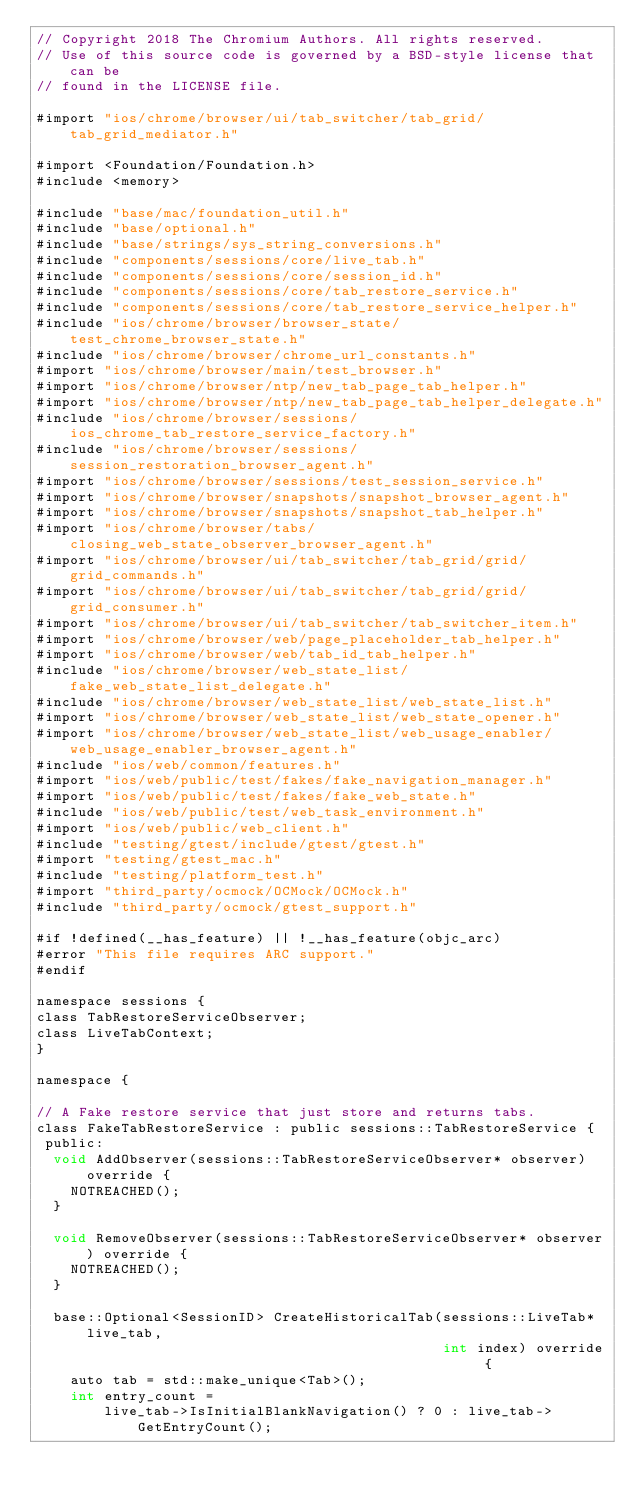<code> <loc_0><loc_0><loc_500><loc_500><_ObjectiveC_>// Copyright 2018 The Chromium Authors. All rights reserved.
// Use of this source code is governed by a BSD-style license that can be
// found in the LICENSE file.

#import "ios/chrome/browser/ui/tab_switcher/tab_grid/tab_grid_mediator.h"

#import <Foundation/Foundation.h>
#include <memory>

#include "base/mac/foundation_util.h"
#include "base/optional.h"
#include "base/strings/sys_string_conversions.h"
#include "components/sessions/core/live_tab.h"
#include "components/sessions/core/session_id.h"
#include "components/sessions/core/tab_restore_service.h"
#include "components/sessions/core/tab_restore_service_helper.h"
#include "ios/chrome/browser/browser_state/test_chrome_browser_state.h"
#include "ios/chrome/browser/chrome_url_constants.h"
#import "ios/chrome/browser/main/test_browser.h"
#import "ios/chrome/browser/ntp/new_tab_page_tab_helper.h"
#import "ios/chrome/browser/ntp/new_tab_page_tab_helper_delegate.h"
#include "ios/chrome/browser/sessions/ios_chrome_tab_restore_service_factory.h"
#include "ios/chrome/browser/sessions/session_restoration_browser_agent.h"
#import "ios/chrome/browser/sessions/test_session_service.h"
#import "ios/chrome/browser/snapshots/snapshot_browser_agent.h"
#import "ios/chrome/browser/snapshots/snapshot_tab_helper.h"
#import "ios/chrome/browser/tabs/closing_web_state_observer_browser_agent.h"
#import "ios/chrome/browser/ui/tab_switcher/tab_grid/grid/grid_commands.h"
#import "ios/chrome/browser/ui/tab_switcher/tab_grid/grid/grid_consumer.h"
#import "ios/chrome/browser/ui/tab_switcher/tab_switcher_item.h"
#import "ios/chrome/browser/web/page_placeholder_tab_helper.h"
#import "ios/chrome/browser/web/tab_id_tab_helper.h"
#include "ios/chrome/browser/web_state_list/fake_web_state_list_delegate.h"
#include "ios/chrome/browser/web_state_list/web_state_list.h"
#import "ios/chrome/browser/web_state_list/web_state_opener.h"
#import "ios/chrome/browser/web_state_list/web_usage_enabler/web_usage_enabler_browser_agent.h"
#include "ios/web/common/features.h"
#import "ios/web/public/test/fakes/fake_navigation_manager.h"
#import "ios/web/public/test/fakes/fake_web_state.h"
#include "ios/web/public/test/web_task_environment.h"
#import "ios/web/public/web_client.h"
#include "testing/gtest/include/gtest/gtest.h"
#import "testing/gtest_mac.h"
#include "testing/platform_test.h"
#import "third_party/ocmock/OCMock/OCMock.h"
#include "third_party/ocmock/gtest_support.h"

#if !defined(__has_feature) || !__has_feature(objc_arc)
#error "This file requires ARC support."
#endif

namespace sessions {
class TabRestoreServiceObserver;
class LiveTabContext;
}

namespace {

// A Fake restore service that just store and returns tabs.
class FakeTabRestoreService : public sessions::TabRestoreService {
 public:
  void AddObserver(sessions::TabRestoreServiceObserver* observer) override {
    NOTREACHED();
  }

  void RemoveObserver(sessions::TabRestoreServiceObserver* observer) override {
    NOTREACHED();
  }

  base::Optional<SessionID> CreateHistoricalTab(sessions::LiveTab* live_tab,
                                                int index) override {
    auto tab = std::make_unique<Tab>();
    int entry_count =
        live_tab->IsInitialBlankNavigation() ? 0 : live_tab->GetEntryCount();</code> 